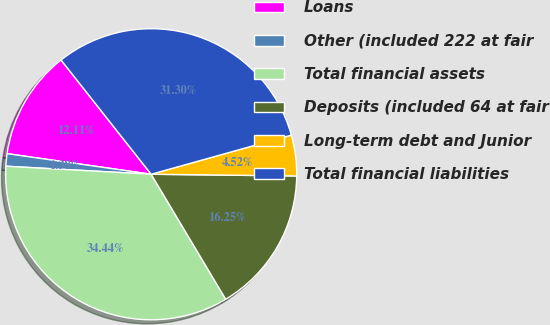<chart> <loc_0><loc_0><loc_500><loc_500><pie_chart><fcel>Loans<fcel>Other (included 222 at fair<fcel>Total financial assets<fcel>Deposits (included 64 at fair<fcel>Long-term debt and Junior<fcel>Total financial liabilities<nl><fcel>12.11%<fcel>1.38%<fcel>34.44%<fcel>16.25%<fcel>4.52%<fcel>31.3%<nl></chart> 